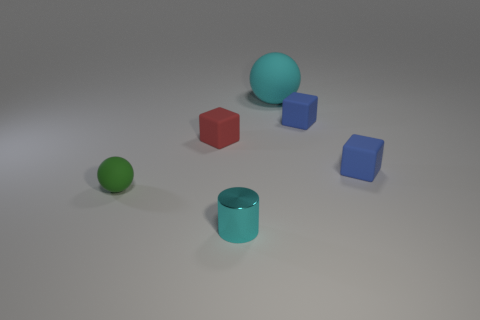Does the tiny ball have the same material as the red block?
Ensure brevity in your answer.  Yes. There is a rubber ball behind the rubber sphere that is left of the ball to the right of the small green ball; how big is it?
Give a very brief answer. Large. How many other things are there of the same color as the small rubber ball?
Give a very brief answer. 0. What shape is the red object that is the same size as the cyan metal cylinder?
Offer a very short reply. Cube. How many small things are cyan metallic things or red blocks?
Offer a very short reply. 2. There is a blue matte thing that is to the left of the small cube that is in front of the red block; is there a blue matte cube that is right of it?
Your response must be concise. Yes. Are there any yellow shiny cylinders of the same size as the green thing?
Provide a short and direct response. No. There is a cyan object that is the same size as the green rubber object; what material is it?
Give a very brief answer. Metal. There is a cyan metallic object; is its size the same as the matte block in front of the small red rubber thing?
Give a very brief answer. Yes. How many metallic objects are either brown things or blocks?
Provide a short and direct response. 0. 